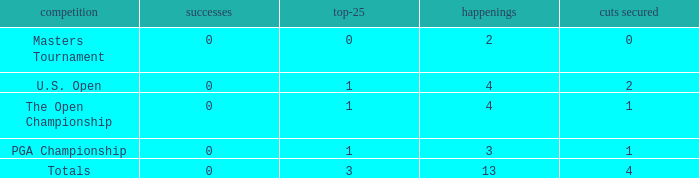How many cuts did he make at the PGA championship in 3 events? None. 